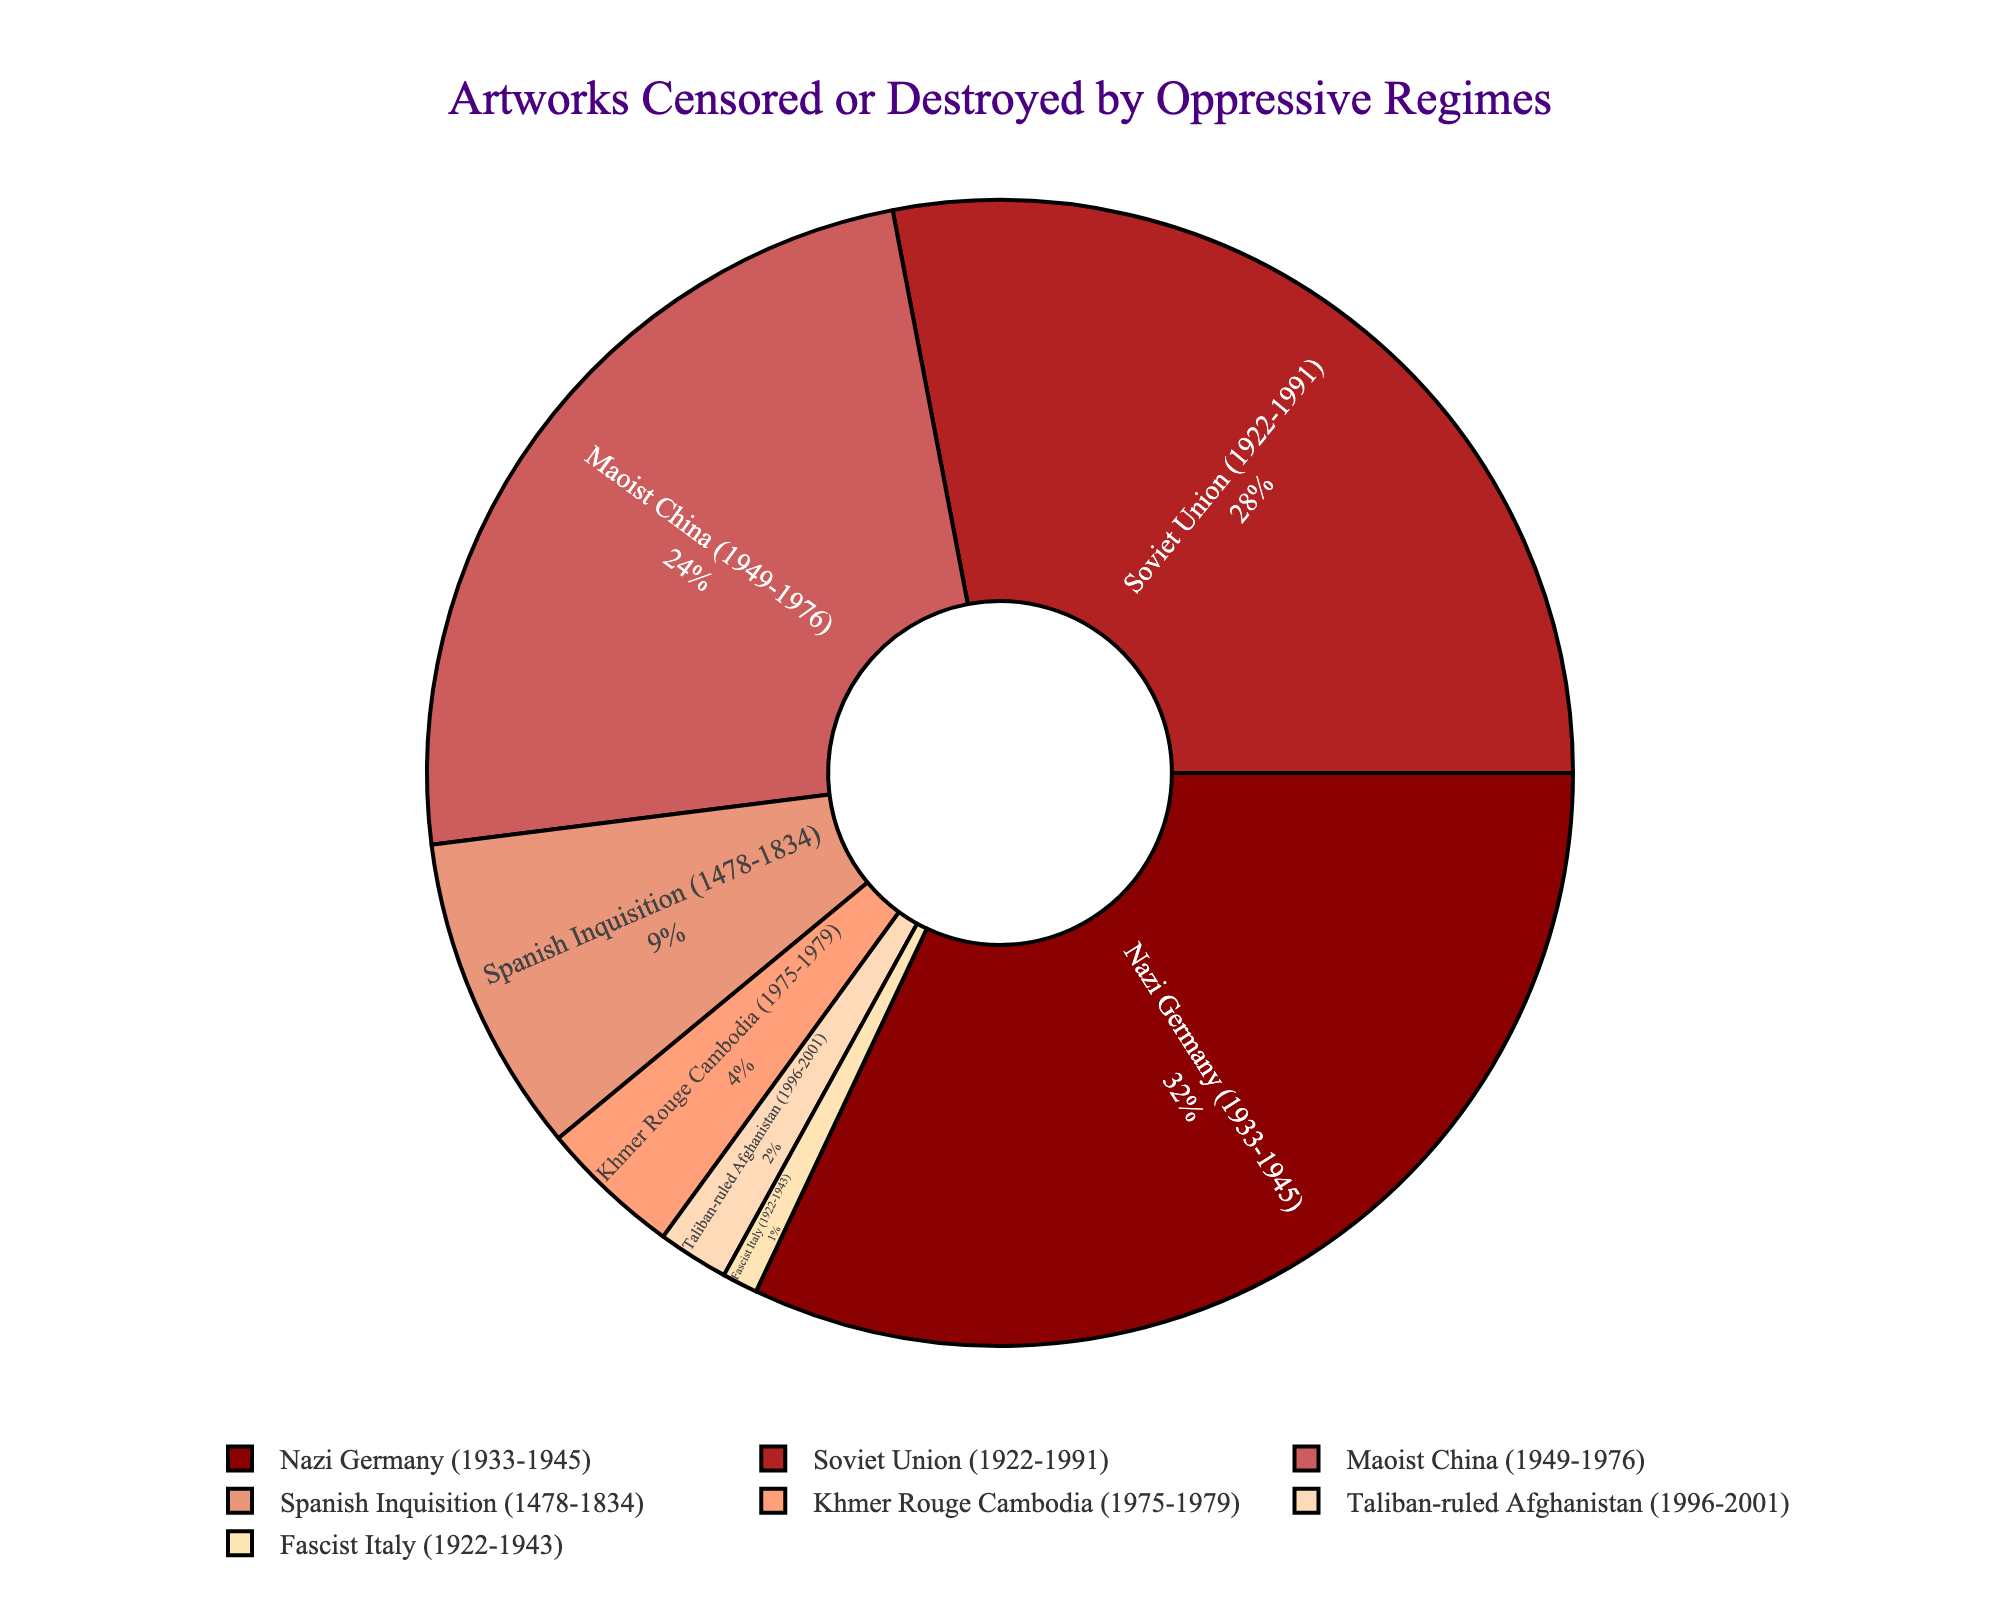Which historical period has the highest percentage of artworks censored or destroyed? Observe the pie chart to see which segment is the largest. The Nazi Germany (1933-1945) period segment is the largest.
Answer: Nazi Germany (1933-1945) Which historical period has the smallest percentage of artworks censored or destroyed? Observe the pie chart to see which segment is the smallest. The Fascist Italy (1922-1943) period segment is the smallest.
Answer: Fascist Italy (1922-1943) What is the combined percentage of artworks censored or destroyed by the Soviet Union and Maoist China? Add the percentages of Soviet Union (28%) and Maoist China (24%). 28 + 24 = 52%.
Answer: 52% Which periods have a combined percentage greater than the Spanish Inquisition? Check the percentages for each period and identify combinations that exceed 9%. Khmer Rouge (4%) + Taliban-ruled Afghanistan (2%) + Fascist Italy (1%) = 7% < 9%, so no combination listed has a combined percentage that exceeds the Spanish Inquisition.
Answer: None Which periods' segments are visually similar in size? Compare the sizes of the segments in the pie chart visually. The Soviet Union (28%) and Maoist China (24%) segments are visually similar.
Answer: Soviet Union (1922-1991) and Maoist China (1949-1976) Which three periods together account for more than half of the total percentage? Add the percentages together until the sum exceeds 50%. Nazi Germany (32%) + Soviet Union (28%) = 60%, which is already over half.
Answer: Nazi Germany, Soviet Union How much larger is the Nazi Germany segment compared to the Khmer Rouge Cambodia segment? Subtract the percentage of Khmer Rouge Cambodia (4%) from Nazi Germany (32%). 32 - 4 = 28%.
Answer: 28% Which historical periods combined have exactly half the total percentage? Calculate the sum of the percentages that add up to exactly 50%. Spanish Inquisition (9%) + Maoist China (24%) + Khmer Rouge Cambodia (4%) + Taliban-ruled Afghanistan (2%) + Fascist Italy (1%) = 40%, is less. So combining Soviet Union (28%) and Spanish Inquisition (9%) and Khmer Rouge Cambodia (4%) and Taliban-ruled Afghanistan (2%) and Fascist Italy (1%) = 44 less. So no combination exactly 50%.
Answer: None Which period comes second in terms of the percentage of artworks censored or destroyed? Identify the second-largest segment visually, which follows the largest segment for Nazi Germany. The second-largest segment belongs to the Soviet Union (1922-1991) with 28%.
Answer: Soviet Union (1922-1991) 